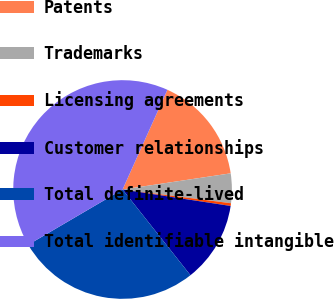<chart> <loc_0><loc_0><loc_500><loc_500><pie_chart><fcel>Patents<fcel>Trademarks<fcel>Licensing agreements<fcel>Customer relationships<fcel>Total definite-lived<fcel>Total identifiable intangible<nl><fcel>15.91%<fcel>4.37%<fcel>0.4%<fcel>11.93%<fcel>27.23%<fcel>40.16%<nl></chart> 